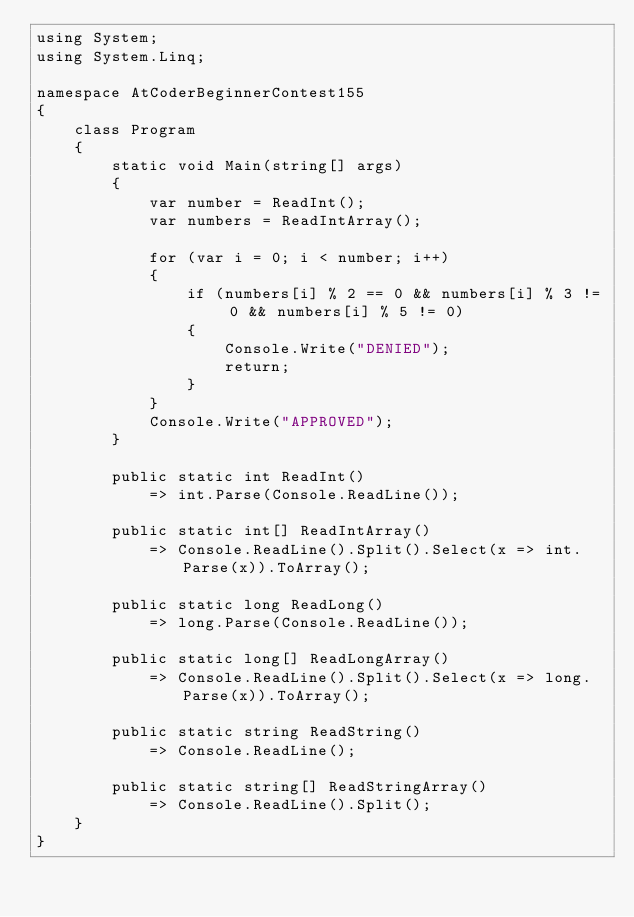Convert code to text. <code><loc_0><loc_0><loc_500><loc_500><_C#_>using System;
using System.Linq;

namespace AtCoderBeginnerContest155
{
	class Program
	{
		static void Main(string[] args)
		{
			var number = ReadInt();
			var numbers = ReadIntArray();

			for (var i = 0; i < number; i++)
			{
				if (numbers[i] % 2 == 0 && numbers[i] % 3 != 0 && numbers[i] % 5 != 0)
				{
					Console.Write("DENIED");
					return;
				}
			}
			Console.Write("APPROVED");
		}

		public static int ReadInt()
			=> int.Parse(Console.ReadLine());

		public static int[] ReadIntArray()
			=> Console.ReadLine().Split().Select(x => int.Parse(x)).ToArray();

		public static long ReadLong()
			=> long.Parse(Console.ReadLine());

		public static long[] ReadLongArray()
			=> Console.ReadLine().Split().Select(x => long.Parse(x)).ToArray();

		public static string ReadString()
			=> Console.ReadLine();

		public static string[] ReadStringArray()
			=> Console.ReadLine().Split();
	}
}
</code> 